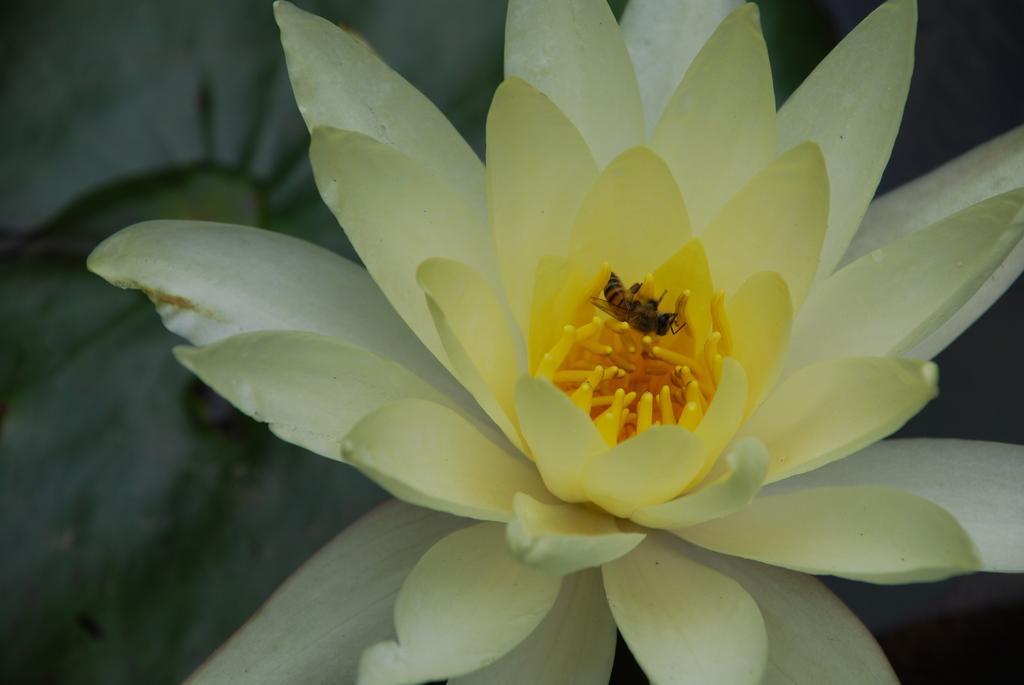Describe this image in one or two sentences. In this image I can see a white flower. I can also see an insect on the flower. 